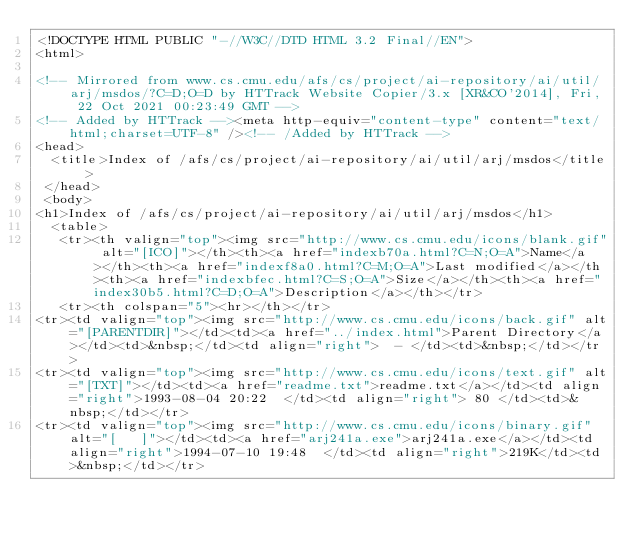Convert code to text. <code><loc_0><loc_0><loc_500><loc_500><_HTML_><!DOCTYPE HTML PUBLIC "-//W3C//DTD HTML 3.2 Final//EN">
<html>
 
<!-- Mirrored from www.cs.cmu.edu/afs/cs/project/ai-repository/ai/util/arj/msdos/?C=D;O=D by HTTrack Website Copier/3.x [XR&CO'2014], Fri, 22 Oct 2021 00:23:49 GMT -->
<!-- Added by HTTrack --><meta http-equiv="content-type" content="text/html;charset=UTF-8" /><!-- /Added by HTTrack -->
<head>
  <title>Index of /afs/cs/project/ai-repository/ai/util/arj/msdos</title>
 </head>
 <body>
<h1>Index of /afs/cs/project/ai-repository/ai/util/arj/msdos</h1>
  <table>
   <tr><th valign="top"><img src="http://www.cs.cmu.edu/icons/blank.gif" alt="[ICO]"></th><th><a href="indexb70a.html?C=N;O=A">Name</a></th><th><a href="indexf8a0.html?C=M;O=A">Last modified</a></th><th><a href="indexbfec.html?C=S;O=A">Size</a></th><th><a href="index30b5.html?C=D;O=A">Description</a></th></tr>
   <tr><th colspan="5"><hr></th></tr>
<tr><td valign="top"><img src="http://www.cs.cmu.edu/icons/back.gif" alt="[PARENTDIR]"></td><td><a href="../index.html">Parent Directory</a></td><td>&nbsp;</td><td align="right">  - </td><td>&nbsp;</td></tr>
<tr><td valign="top"><img src="http://www.cs.cmu.edu/icons/text.gif" alt="[TXT]"></td><td><a href="readme.txt">readme.txt</a></td><td align="right">1993-08-04 20:22  </td><td align="right"> 80 </td><td>&nbsp;</td></tr>
<tr><td valign="top"><img src="http://www.cs.cmu.edu/icons/binary.gif" alt="[   ]"></td><td><a href="arj241a.exe">arj241a.exe</a></td><td align="right">1994-07-10 19:48  </td><td align="right">219K</td><td>&nbsp;</td></tr></code> 